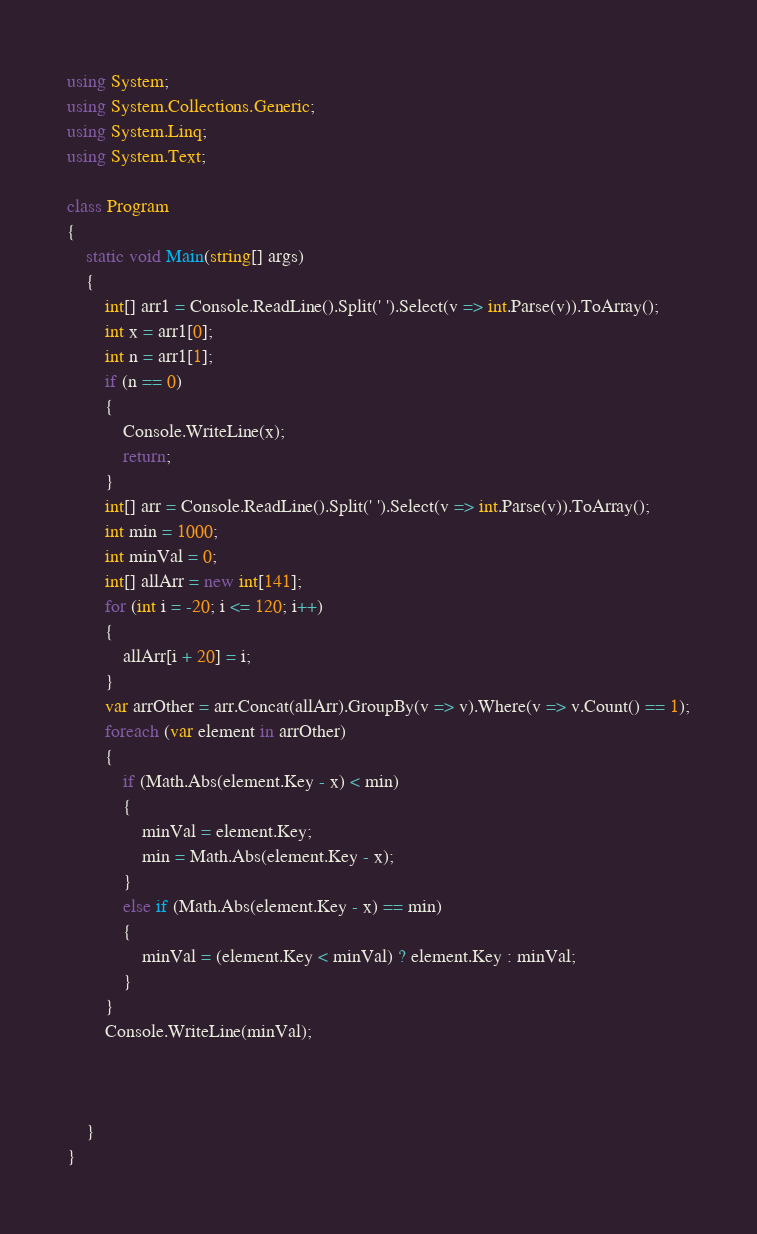<code> <loc_0><loc_0><loc_500><loc_500><_C#_>using System;
using System.Collections.Generic;
using System.Linq;
using System.Text;

class Program
{
    static void Main(string[] args)
    {
        int[] arr1 = Console.ReadLine().Split(' ').Select(v => int.Parse(v)).ToArray();
        int x = arr1[0];
        int n = arr1[1];
        if (n == 0)
        {
            Console.WriteLine(x);
            return;
        }
        int[] arr = Console.ReadLine().Split(' ').Select(v => int.Parse(v)).ToArray();
        int min = 1000;
        int minVal = 0;
        int[] allArr = new int[141];
        for (int i = -20; i <= 120; i++)
        {
            allArr[i + 20] = i;
        }
        var arrOther = arr.Concat(allArr).GroupBy(v => v).Where(v => v.Count() == 1);
        foreach (var element in arrOther)
        {
            if (Math.Abs(element.Key - x) < min)
            {
                minVal = element.Key;
                min = Math.Abs(element.Key - x);
            }
            else if (Math.Abs(element.Key - x) == min)
            {
                minVal = (element.Key < minVal) ? element.Key : minVal;
            }
        }
        Console.WriteLine(minVal);



    }
}</code> 